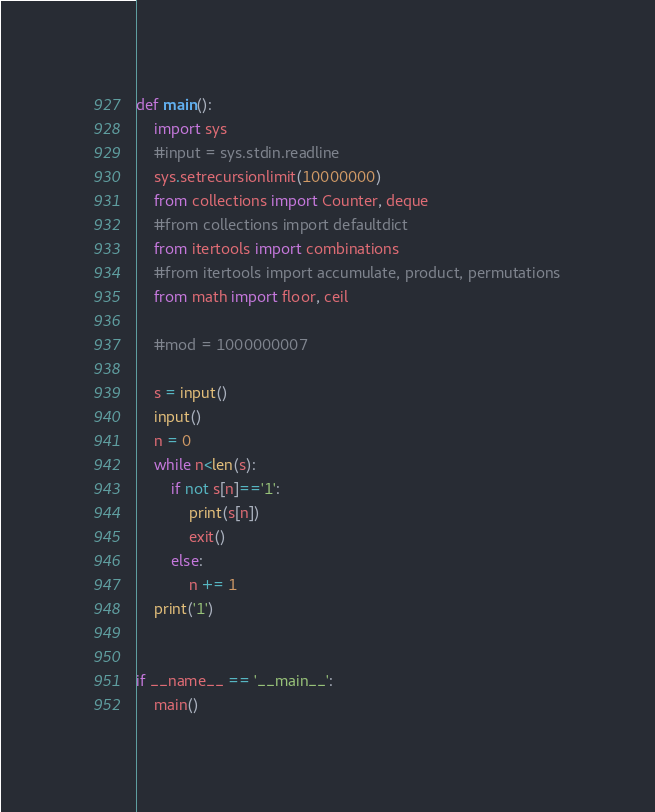<code> <loc_0><loc_0><loc_500><loc_500><_Python_>def main():
    import sys
    #input = sys.stdin.readline
    sys.setrecursionlimit(10000000)
    from collections import Counter, deque
    #from collections import defaultdict
    from itertools import combinations
    #from itertools import accumulate, product, permutations
    from math import floor, ceil

    #mod = 1000000007

    s = input()
    input()
    n = 0
    while n<len(s):
        if not s[n]=='1':
            print(s[n])
            exit()
        else:
            n += 1
    print('1')


if __name__ == '__main__':
    main()</code> 